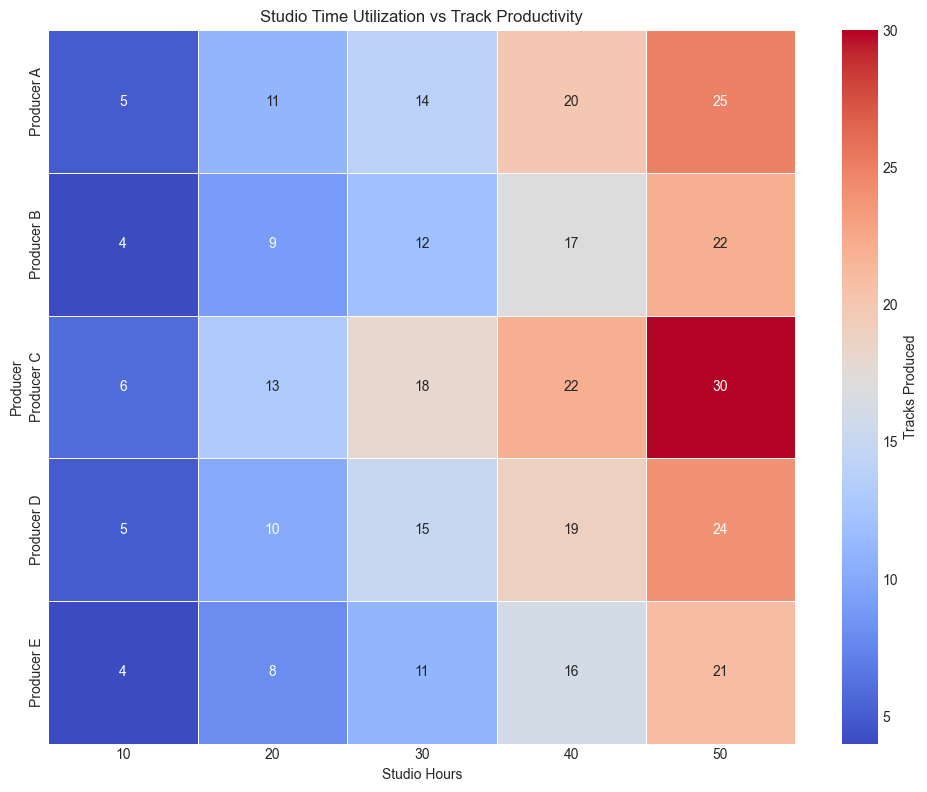What is the maximum number of tracks produced by any producer for 30 studio hours? To find the answer, look at the column corresponding to 30 studio hours and identify the highest number across all producers. The numbers in this column are 14, 12, 18, 15, and 11. The highest number is 18.
Answer: 18 Which producer has the highest productivity for 50 studio hours? To answer, check the row labeled "50 studio hours" and find the producer with the highest number. The values are 25, 22, 30, 24, and 21. Producer C has the highest number, which is 30.
Answer: Producer C Compare the productivity of Producer A and Producer B for 20 studio hours. Who produced more tracks and by how many? Examine the 20 studio hours column for both producers. Producer A produced 11 tracks and Producer B produced 9 tracks. The difference is 11 - 9 = 2.
Answer: Producer A by 2 tracks What is the average number of tracks produced by Producer C for all given studio hours? Calculate the average for Producer C’s values: (6 + 13 + 18 + 22 + 30) / 5. The sum is 89 and dividing by 5 gives 17.8.
Answer: 17.8 Which studio hour showed the most consistent productivity across all producers, and how consistent was it? Consistency refers to the least variability. Look at each column's range (max - min). For 10 hours: range = 6 - 4 = 2. For 20 hours: range = 13 - 8 = 5. For 30 hours: range = 18 - 11 = 7. For 40 hours: range = 22 - 16 = 6. For 50 hours: range = 30 - 21 = 9. The most consistent is for 10 hours with a range of 2.
Answer: 10 studio hours, range of 2 Which producer shows the greatest increase in productivity from 10 to 20 studio hours? Calculate the increase for each producer:
Producer A: 11 - 5 = 6
Producer B: 9 - 4 = 5
Producer C: 13 - 6 = 7
Producer D: 10 - 5 = 5
Producer E: 8 - 4 = 4. The greatest increase is for Producer C with 7.
Answer: Producer C What is the total number of tracks produced by Producer D for all given studio hours? Sum the values for Producer D: 5 + 10 + 15 + 19 + 24 = 73.
Answer: 73 Is there any point where Producer E produced more tracks than Producer D? If so, when? Compare each hour's values for Producer E and D: 10 hours: 4 < 5, 20 hours: 8 < 10, 30 hours: 11 < 15, 40 hours: 16 < 19, 50 hours: 21 < 24. Producer E never produced more tracks than Producer D.
Answer: No 